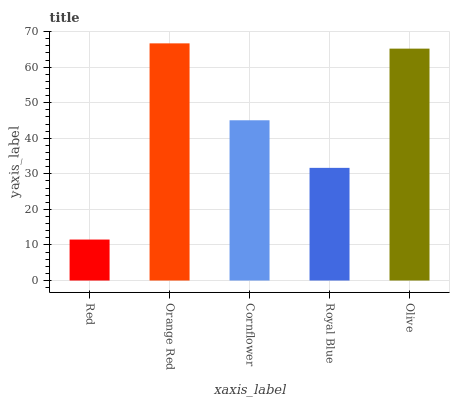Is Red the minimum?
Answer yes or no. Yes. Is Orange Red the maximum?
Answer yes or no. Yes. Is Cornflower the minimum?
Answer yes or no. No. Is Cornflower the maximum?
Answer yes or no. No. Is Orange Red greater than Cornflower?
Answer yes or no. Yes. Is Cornflower less than Orange Red?
Answer yes or no. Yes. Is Cornflower greater than Orange Red?
Answer yes or no. No. Is Orange Red less than Cornflower?
Answer yes or no. No. Is Cornflower the high median?
Answer yes or no. Yes. Is Cornflower the low median?
Answer yes or no. Yes. Is Red the high median?
Answer yes or no. No. Is Royal Blue the low median?
Answer yes or no. No. 